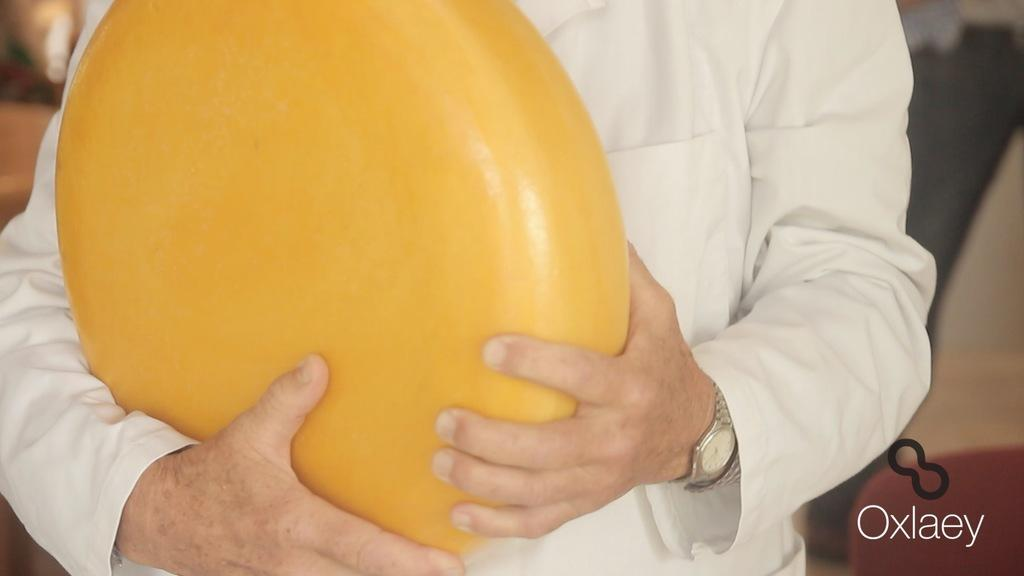What can be seen in the image? There is a person in the image. What is the person holding in their hand? The person is holding an object in their hand. Is there any text present in the image? Yes, there is text written at the bottom of the image. What type of screw is being used to fix the bath in the image? There is no screw or bath present in the image; it only features a person holding an object and text at the bottom. 